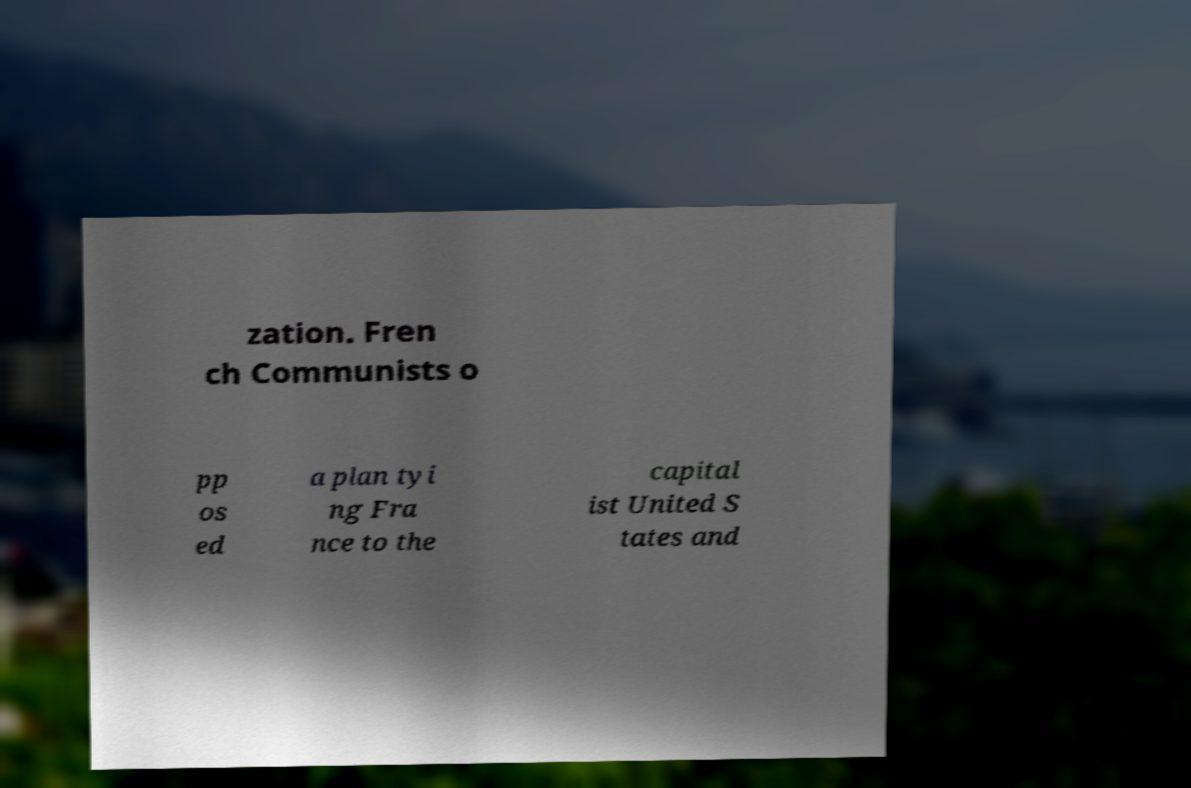There's text embedded in this image that I need extracted. Can you transcribe it verbatim? zation. Fren ch Communists o pp os ed a plan tyi ng Fra nce to the capital ist United S tates and 